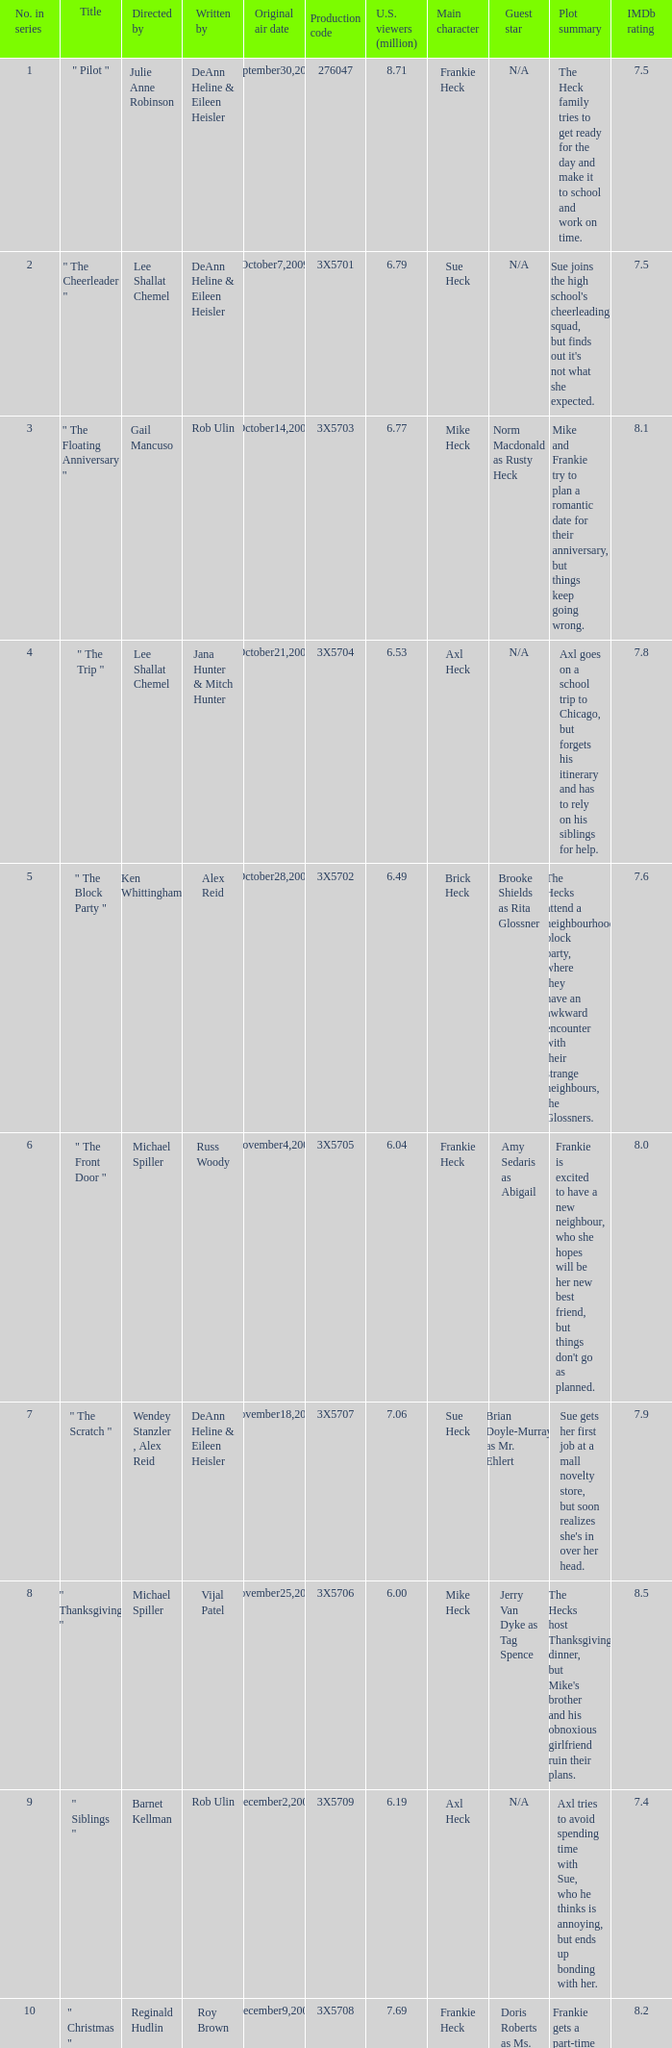Who wrote the episode that got 5.95 million U.S. viewers? Vijal Patel. 